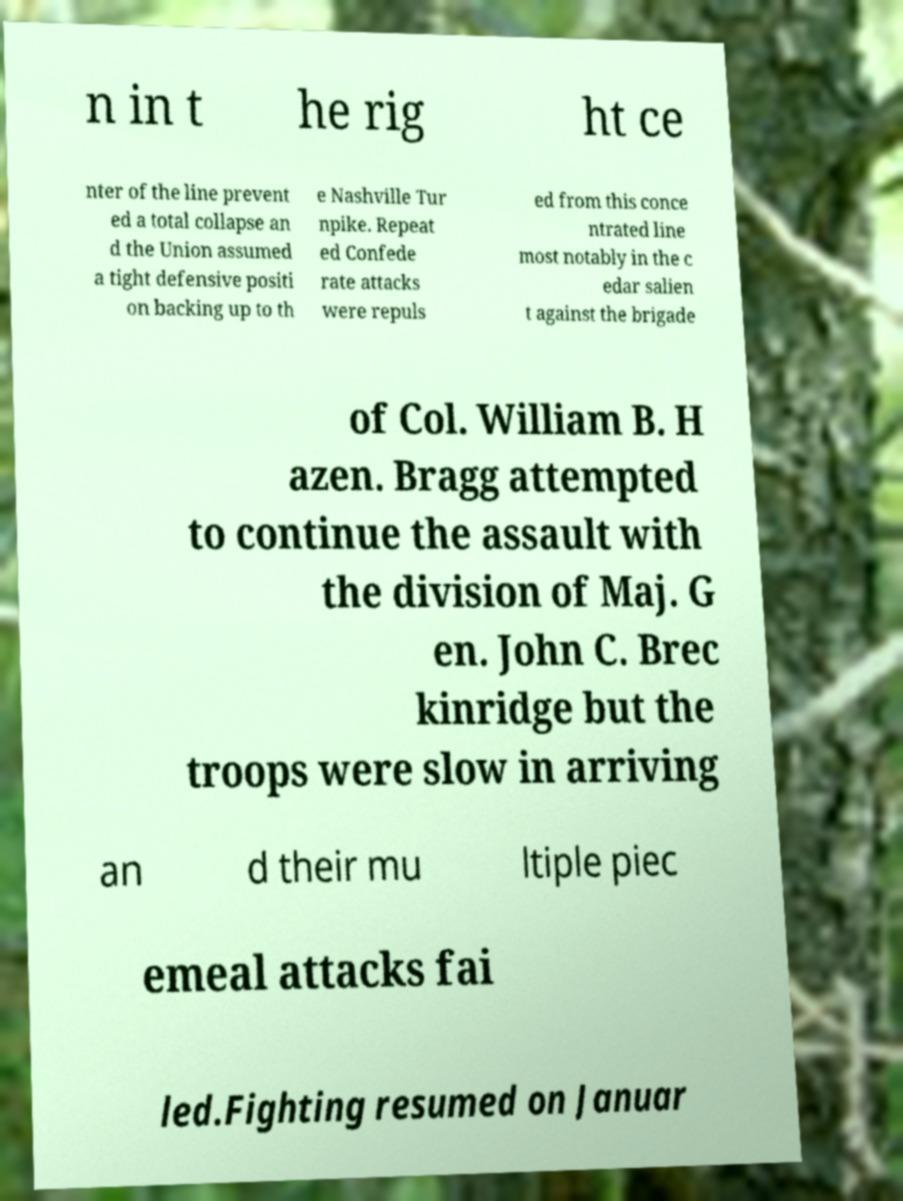For documentation purposes, I need the text within this image transcribed. Could you provide that? n in t he rig ht ce nter of the line prevent ed a total collapse an d the Union assumed a tight defensive positi on backing up to th e Nashville Tur npike. Repeat ed Confede rate attacks were repuls ed from this conce ntrated line most notably in the c edar salien t against the brigade of Col. William B. H azen. Bragg attempted to continue the assault with the division of Maj. G en. John C. Brec kinridge but the troops were slow in arriving an d their mu ltiple piec emeal attacks fai led.Fighting resumed on Januar 